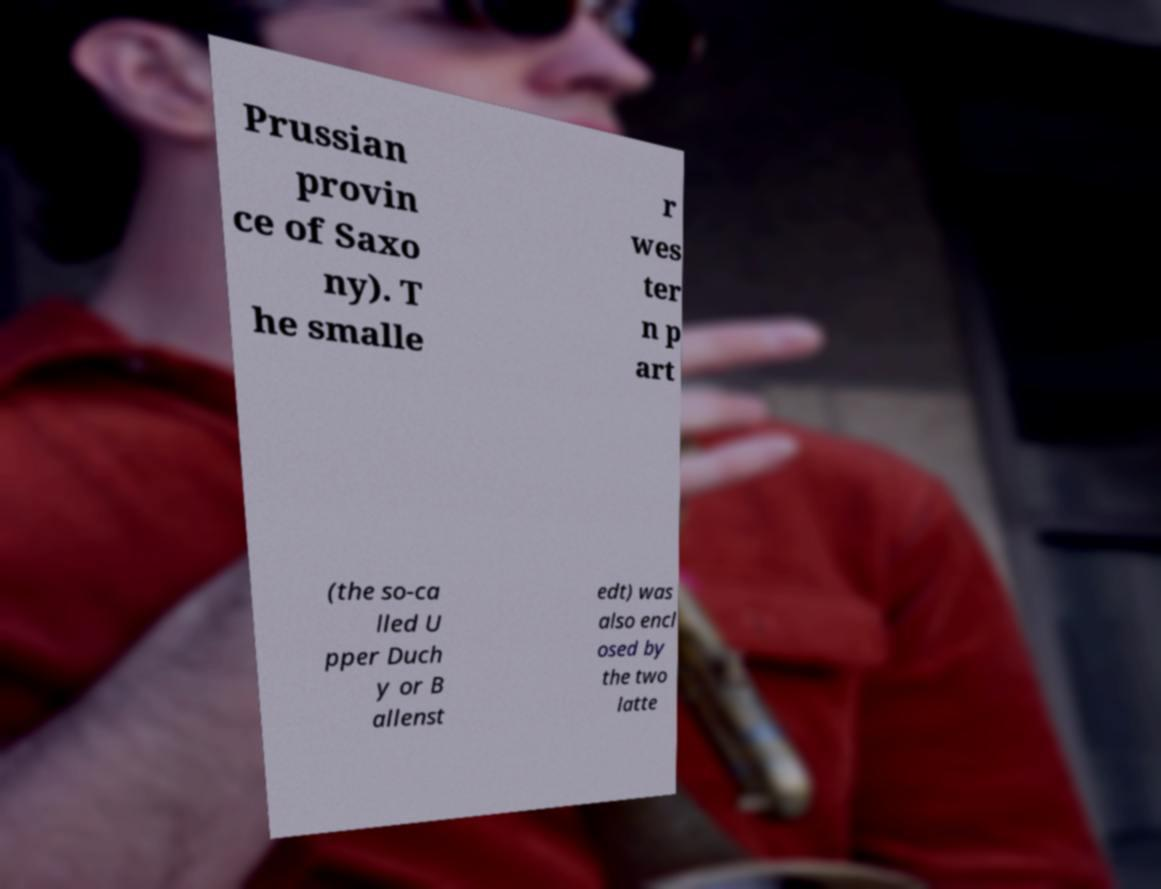For documentation purposes, I need the text within this image transcribed. Could you provide that? Prussian provin ce of Saxo ny). T he smalle r wes ter n p art (the so-ca lled U pper Duch y or B allenst edt) was also encl osed by the two latte 